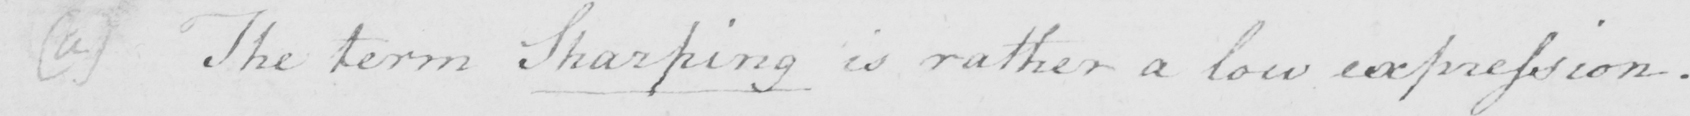What text is written in this handwritten line? ( a )  The term Sharping is rather a low expression . 